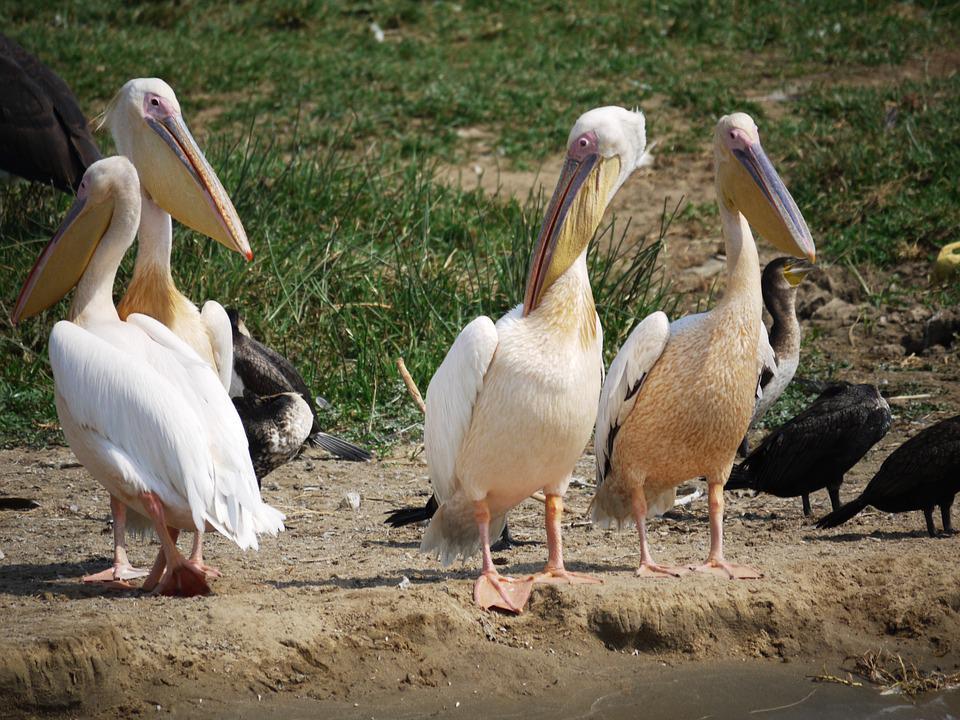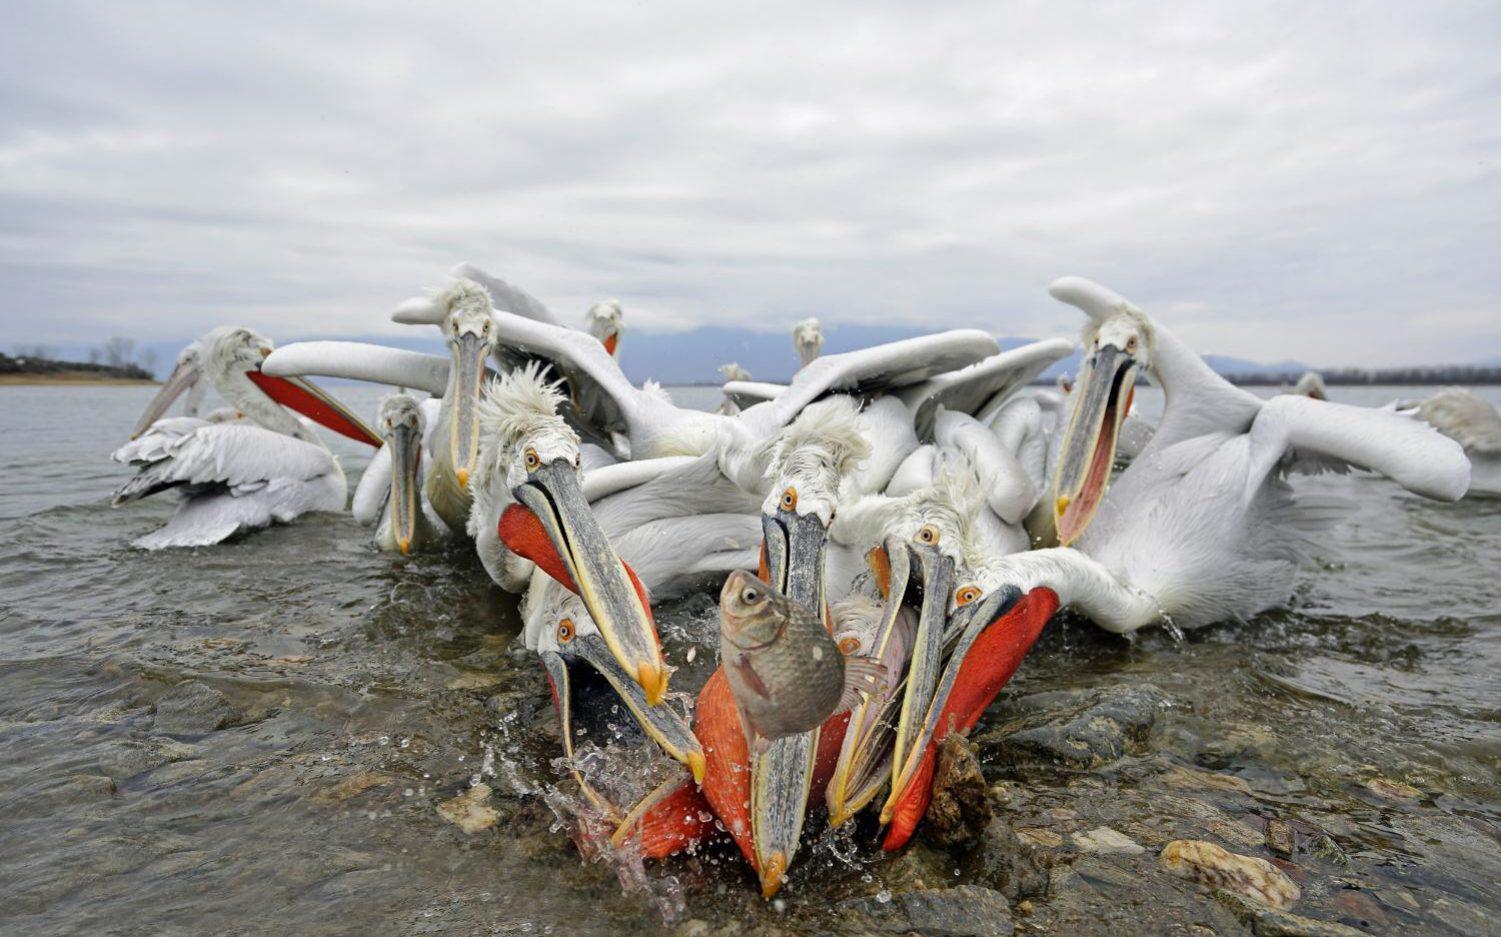The first image is the image on the left, the second image is the image on the right. Given the left and right images, does the statement "At least one bird is flying." hold true? Answer yes or no. No. The first image is the image on the left, the second image is the image on the right. Given the left and right images, does the statement "there is a flying bird in the image on the right" hold true? Answer yes or no. No. 